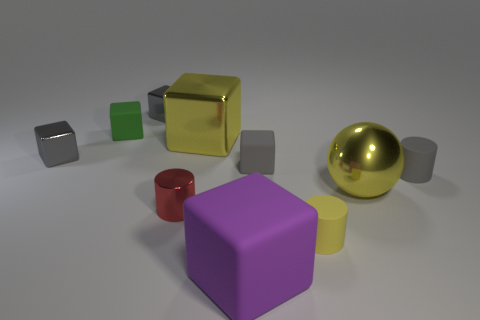There is a metallic cube that is the same color as the metal sphere; what is its size?
Make the answer very short. Large. Are there any small gray cylinders made of the same material as the yellow sphere?
Ensure brevity in your answer.  No. Are there more red cylinders than brown matte things?
Your response must be concise. Yes. Are the red object and the large purple block made of the same material?
Provide a succinct answer. No. How many matte objects are tiny green blocks or brown cubes?
Keep it short and to the point. 1. The matte thing that is the same size as the yellow shiny block is what color?
Offer a very short reply. Purple. How many tiny gray matte things are the same shape as the purple object?
Your answer should be very brief. 1. What number of cylinders are either gray rubber objects or tiny gray objects?
Your answer should be very brief. 1. There is a yellow rubber object that is in front of the red shiny cylinder; does it have the same shape as the green rubber thing behind the large yellow sphere?
Ensure brevity in your answer.  No. What material is the large yellow ball?
Your response must be concise. Metal. 